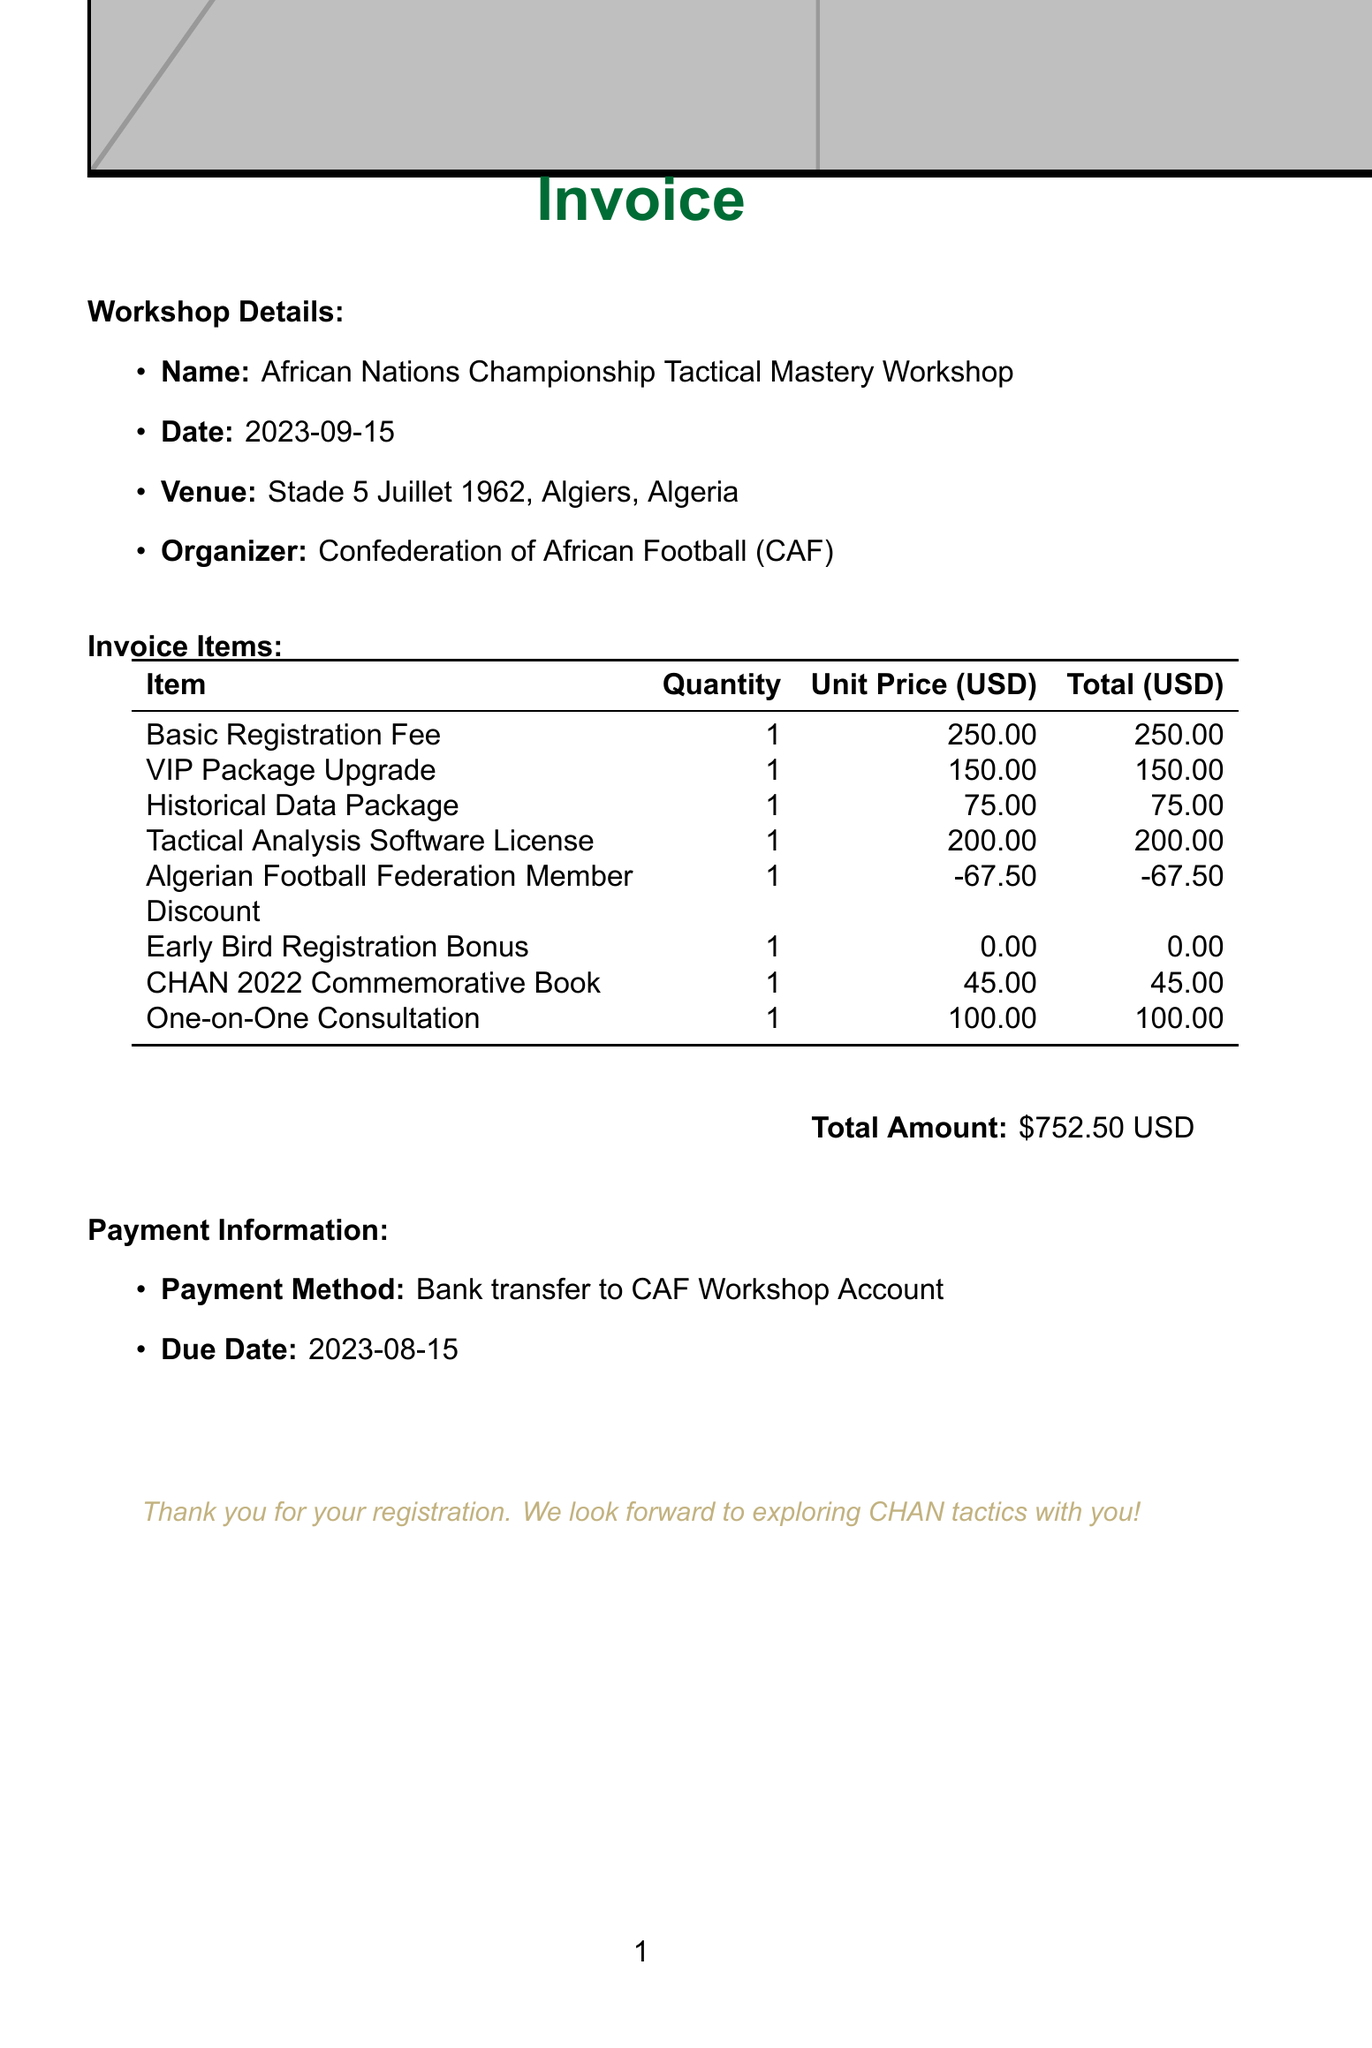What is the workshop name? The workshop name is provided in the document under workshop details, which is "African Nations Championship Tactical Mastery Workshop".
Answer: African Nations Championship Tactical Mastery Workshop What is the total amount due? The total amount due is explicitly mentioned in the payment information section of the document, which totals $752.50.
Answer: $752.50 Who is the guest speaker at the post-workshop dinner? The guest speaker for the exclusive dinner is mentioned in the VIP Package Upgrade description, which is Djamel Belmadi.
Answer: Djamel Belmadi What is the payment method? The payment method is clearly stated in the payment information section as "Bank transfer to CAF Workshop Account".
Answer: Bank transfer to CAF Workshop Account What is the due date for payment? The due date for payment is provided in the payment information section, stating "2023-08-15".
Answer: 2023-08-15 How much is the Historical Data Package? The price of the Historical Data Package is found in the invoice items table, which lists it at $75.00.
Answer: $75.00 What is included in the Early Bird Registration Bonus? The Early Bird Registration Bonus is described in the document and indicates a free entry to a specific masterclass by Vahid Halilhodžić.
Answer: Free entry to 'Evolution of North African Tactics' masterclass What discount do FAF members receive? The document states that FAF members get a 10% discount, which is reflected as a deduction of $67.50 in the invoice items.
Answer: 10% discount What is the venue for the workshop? The venue for the workshop is specified under workshop details as "Stade 5 Juillet 1962, Algiers, Algeria".
Answer: Stade 5 Juillet 1962, Algiers, Algeria 